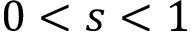Convert formula to latex. <formula><loc_0><loc_0><loc_500><loc_500>0 < s < 1</formula> 